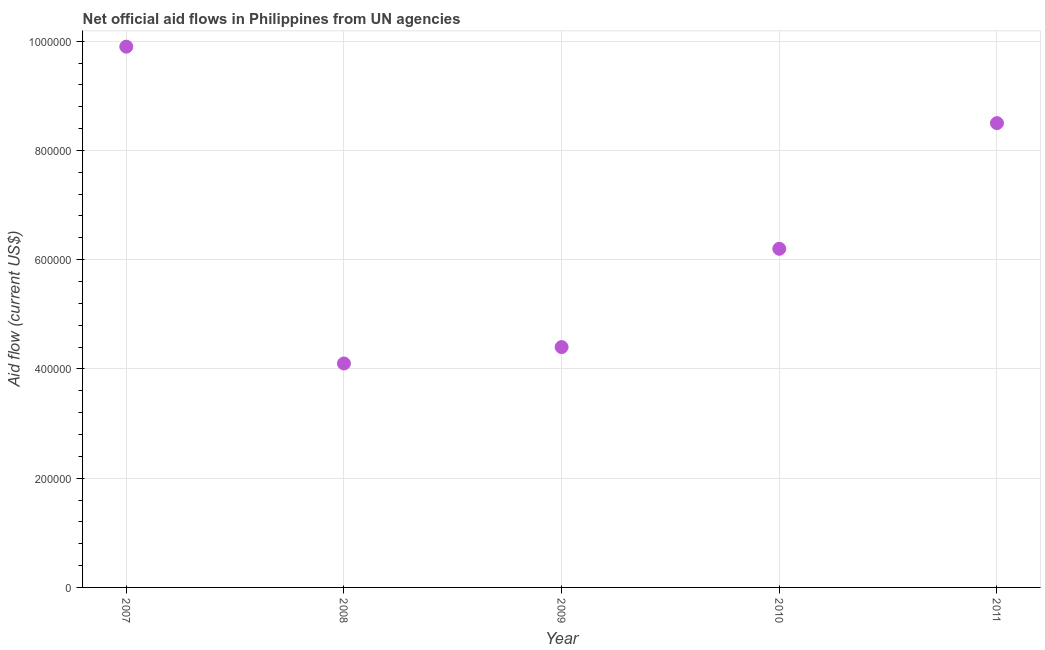What is the net official flows from un agencies in 2008?
Give a very brief answer. 4.10e+05. Across all years, what is the maximum net official flows from un agencies?
Provide a succinct answer. 9.90e+05. Across all years, what is the minimum net official flows from un agencies?
Provide a succinct answer. 4.10e+05. In which year was the net official flows from un agencies minimum?
Provide a short and direct response. 2008. What is the sum of the net official flows from un agencies?
Your response must be concise. 3.31e+06. What is the difference between the net official flows from un agencies in 2007 and 2008?
Offer a terse response. 5.80e+05. What is the average net official flows from un agencies per year?
Keep it short and to the point. 6.62e+05. What is the median net official flows from un agencies?
Your answer should be very brief. 6.20e+05. In how many years, is the net official flows from un agencies greater than 160000 US$?
Ensure brevity in your answer.  5. Do a majority of the years between 2007 and 2008 (inclusive) have net official flows from un agencies greater than 80000 US$?
Provide a short and direct response. Yes. What is the ratio of the net official flows from un agencies in 2007 to that in 2011?
Keep it short and to the point. 1.16. Is the net official flows from un agencies in 2009 less than that in 2010?
Provide a short and direct response. Yes. Is the difference between the net official flows from un agencies in 2008 and 2010 greater than the difference between any two years?
Your answer should be compact. No. What is the difference between the highest and the second highest net official flows from un agencies?
Offer a terse response. 1.40e+05. Is the sum of the net official flows from un agencies in 2008 and 2009 greater than the maximum net official flows from un agencies across all years?
Give a very brief answer. No. What is the difference between the highest and the lowest net official flows from un agencies?
Offer a very short reply. 5.80e+05. In how many years, is the net official flows from un agencies greater than the average net official flows from un agencies taken over all years?
Offer a terse response. 2. Are the values on the major ticks of Y-axis written in scientific E-notation?
Give a very brief answer. No. Does the graph contain any zero values?
Your answer should be compact. No. What is the title of the graph?
Your answer should be compact. Net official aid flows in Philippines from UN agencies. What is the label or title of the X-axis?
Your response must be concise. Year. What is the label or title of the Y-axis?
Offer a very short reply. Aid flow (current US$). What is the Aid flow (current US$) in 2007?
Ensure brevity in your answer.  9.90e+05. What is the Aid flow (current US$) in 2008?
Your response must be concise. 4.10e+05. What is the Aid flow (current US$) in 2009?
Your answer should be compact. 4.40e+05. What is the Aid flow (current US$) in 2010?
Provide a succinct answer. 6.20e+05. What is the Aid flow (current US$) in 2011?
Your response must be concise. 8.50e+05. What is the difference between the Aid flow (current US$) in 2007 and 2008?
Make the answer very short. 5.80e+05. What is the difference between the Aid flow (current US$) in 2007 and 2010?
Provide a short and direct response. 3.70e+05. What is the difference between the Aid flow (current US$) in 2007 and 2011?
Ensure brevity in your answer.  1.40e+05. What is the difference between the Aid flow (current US$) in 2008 and 2010?
Offer a terse response. -2.10e+05. What is the difference between the Aid flow (current US$) in 2008 and 2011?
Offer a terse response. -4.40e+05. What is the difference between the Aid flow (current US$) in 2009 and 2010?
Keep it short and to the point. -1.80e+05. What is the difference between the Aid flow (current US$) in 2009 and 2011?
Ensure brevity in your answer.  -4.10e+05. What is the ratio of the Aid flow (current US$) in 2007 to that in 2008?
Your answer should be very brief. 2.42. What is the ratio of the Aid flow (current US$) in 2007 to that in 2009?
Give a very brief answer. 2.25. What is the ratio of the Aid flow (current US$) in 2007 to that in 2010?
Give a very brief answer. 1.6. What is the ratio of the Aid flow (current US$) in 2007 to that in 2011?
Your response must be concise. 1.17. What is the ratio of the Aid flow (current US$) in 2008 to that in 2009?
Give a very brief answer. 0.93. What is the ratio of the Aid flow (current US$) in 2008 to that in 2010?
Make the answer very short. 0.66. What is the ratio of the Aid flow (current US$) in 2008 to that in 2011?
Your answer should be compact. 0.48. What is the ratio of the Aid flow (current US$) in 2009 to that in 2010?
Make the answer very short. 0.71. What is the ratio of the Aid flow (current US$) in 2009 to that in 2011?
Keep it short and to the point. 0.52. What is the ratio of the Aid flow (current US$) in 2010 to that in 2011?
Your answer should be very brief. 0.73. 